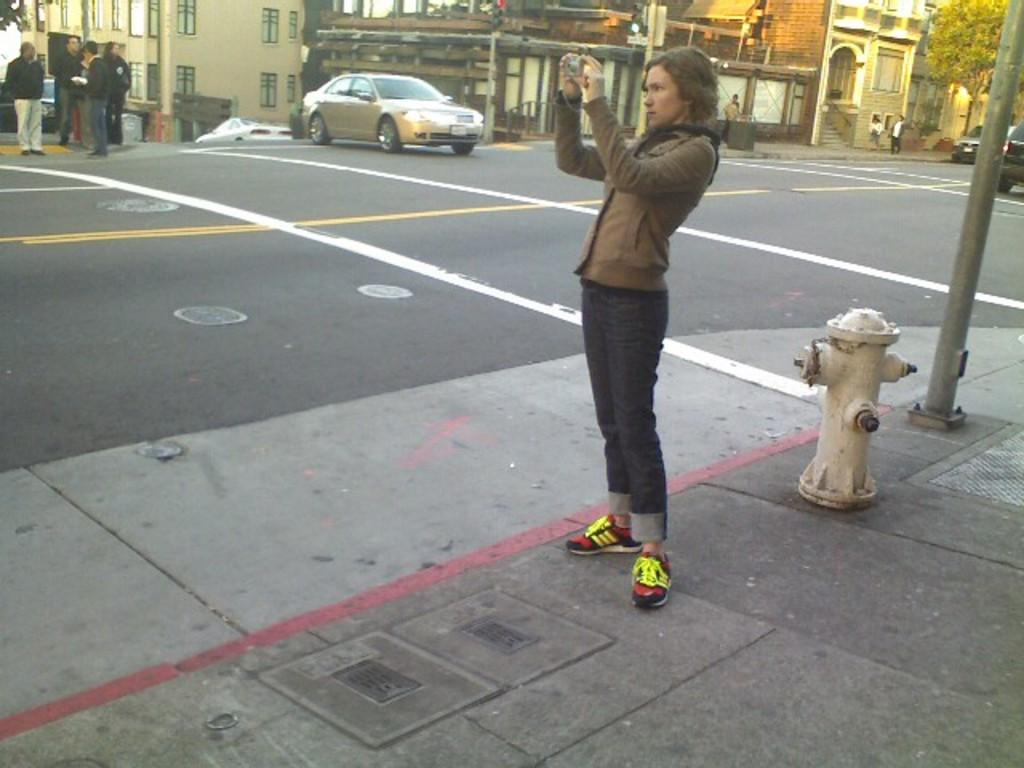What can be seen on the road in the image? There are people on the road in the image. What else is present on the road besides people? There are vehicles in the image. What can be seen in the background of the image? There are buildings and trees visible in the image. What safety feature is present in the image? There is a fire hydrant in the image. Can you see any quicksand on the road in the image? No, there is no quicksand present in the image. What type of fork is being used by the people in the image? There are no forks present in the image; it features people on the road and vehicles. 